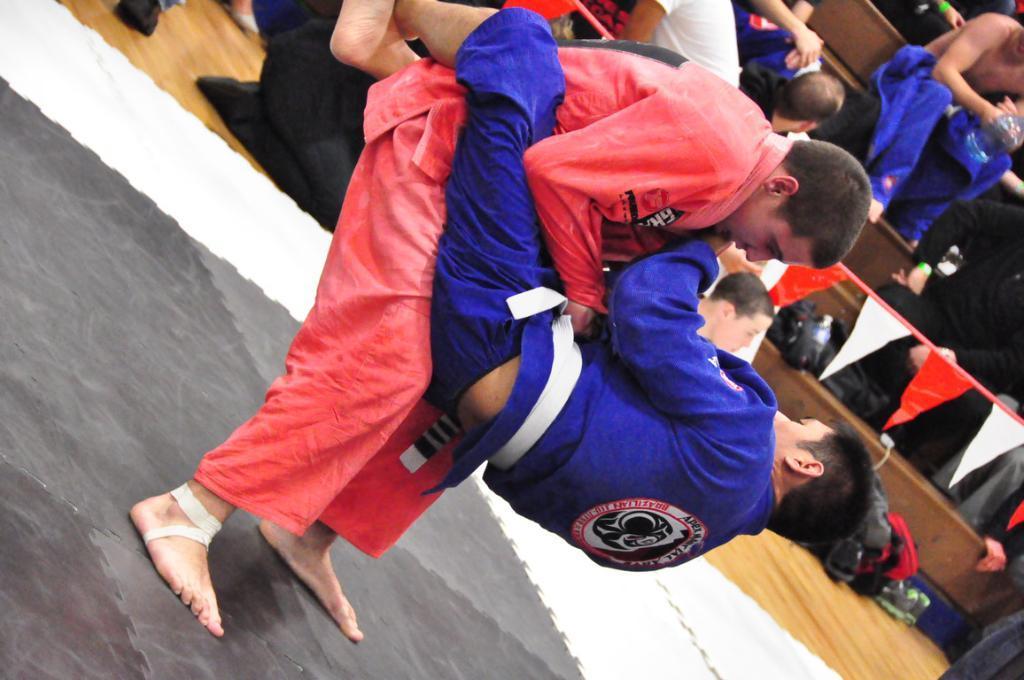Can you describe this image briefly? Here is a man lifting a person. This looks like a paper banner. I can see few people sitting on the wooden stairs. This looks like a bag, which is placed on the floor. 